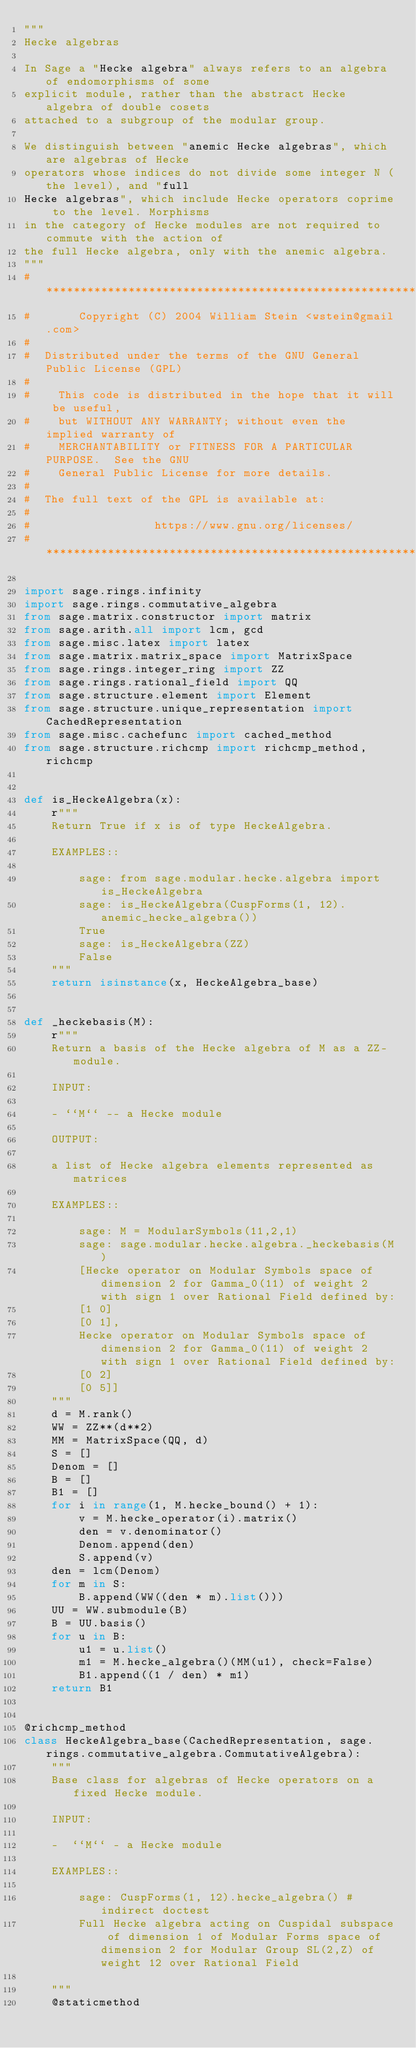<code> <loc_0><loc_0><loc_500><loc_500><_Python_>"""
Hecke algebras

In Sage a "Hecke algebra" always refers to an algebra of endomorphisms of some
explicit module, rather than the abstract Hecke algebra of double cosets
attached to a subgroup of the modular group.

We distinguish between "anemic Hecke algebras", which are algebras of Hecke
operators whose indices do not divide some integer N (the level), and "full
Hecke algebras", which include Hecke operators coprime to the level. Morphisms
in the category of Hecke modules are not required to commute with the action of
the full Hecke algebra, only with the anemic algebra.
"""
# ****************************************************************************
#       Copyright (C) 2004 William Stein <wstein@gmail.com>
#
#  Distributed under the terms of the GNU General Public License (GPL)
#
#    This code is distributed in the hope that it will be useful,
#    but WITHOUT ANY WARRANTY; without even the implied warranty of
#    MERCHANTABILITY or FITNESS FOR A PARTICULAR PURPOSE.  See the GNU
#    General Public License for more details.
#
#  The full text of the GPL is available at:
#
#                  https://www.gnu.org/licenses/
# ****************************************************************************

import sage.rings.infinity
import sage.rings.commutative_algebra
from sage.matrix.constructor import matrix
from sage.arith.all import lcm, gcd
from sage.misc.latex import latex
from sage.matrix.matrix_space import MatrixSpace
from sage.rings.integer_ring import ZZ
from sage.rings.rational_field import QQ
from sage.structure.element import Element
from sage.structure.unique_representation import CachedRepresentation
from sage.misc.cachefunc import cached_method
from sage.structure.richcmp import richcmp_method, richcmp


def is_HeckeAlgebra(x):
    r"""
    Return True if x is of type HeckeAlgebra.

    EXAMPLES::

        sage: from sage.modular.hecke.algebra import is_HeckeAlgebra
        sage: is_HeckeAlgebra(CuspForms(1, 12).anemic_hecke_algebra())
        True
        sage: is_HeckeAlgebra(ZZ)
        False
    """
    return isinstance(x, HeckeAlgebra_base)


def _heckebasis(M):
    r"""
    Return a basis of the Hecke algebra of M as a ZZ-module.

    INPUT:

    - ``M`` -- a Hecke module

    OUTPUT:

    a list of Hecke algebra elements represented as matrices

    EXAMPLES::

        sage: M = ModularSymbols(11,2,1)
        sage: sage.modular.hecke.algebra._heckebasis(M)
        [Hecke operator on Modular Symbols space of dimension 2 for Gamma_0(11) of weight 2 with sign 1 over Rational Field defined by:
        [1 0]
        [0 1],
        Hecke operator on Modular Symbols space of dimension 2 for Gamma_0(11) of weight 2 with sign 1 over Rational Field defined by:
        [0 2]
        [0 5]]
    """
    d = M.rank()
    WW = ZZ**(d**2)
    MM = MatrixSpace(QQ, d)
    S = []
    Denom = []
    B = []
    B1 = []
    for i in range(1, M.hecke_bound() + 1):
        v = M.hecke_operator(i).matrix()
        den = v.denominator()
        Denom.append(den)
        S.append(v)
    den = lcm(Denom)
    for m in S:
        B.append(WW((den * m).list()))
    UU = WW.submodule(B)
    B = UU.basis()
    for u in B:
        u1 = u.list()
        m1 = M.hecke_algebra()(MM(u1), check=False)
        B1.append((1 / den) * m1)
    return B1


@richcmp_method
class HeckeAlgebra_base(CachedRepresentation, sage.rings.commutative_algebra.CommutativeAlgebra):
    """
    Base class for algebras of Hecke operators on a fixed Hecke module.

    INPUT:

    -  ``M`` - a Hecke module

    EXAMPLES::

        sage: CuspForms(1, 12).hecke_algebra() # indirect doctest
        Full Hecke algebra acting on Cuspidal subspace of dimension 1 of Modular Forms space of dimension 2 for Modular Group SL(2,Z) of weight 12 over Rational Field

    """
    @staticmethod</code> 